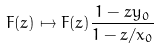<formula> <loc_0><loc_0><loc_500><loc_500>F ( z ) \mapsto F ( z ) \frac { 1 - z y _ { 0 } } { 1 - z / x _ { 0 } }</formula> 